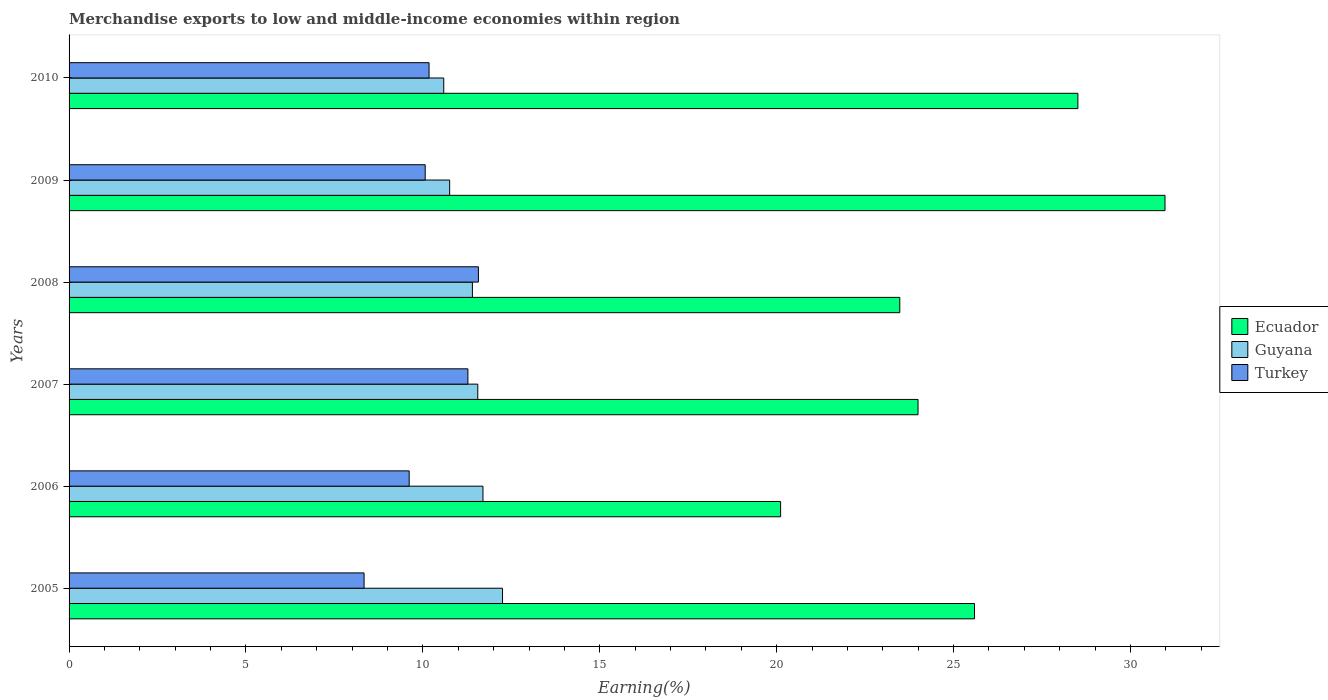Are the number of bars per tick equal to the number of legend labels?
Make the answer very short. Yes. How many bars are there on the 1st tick from the top?
Your answer should be very brief. 3. What is the percentage of amount earned from merchandise exports in Ecuador in 2005?
Provide a succinct answer. 25.59. Across all years, what is the maximum percentage of amount earned from merchandise exports in Ecuador?
Provide a short and direct response. 30.98. Across all years, what is the minimum percentage of amount earned from merchandise exports in Turkey?
Your response must be concise. 8.34. In which year was the percentage of amount earned from merchandise exports in Guyana maximum?
Provide a short and direct response. 2005. In which year was the percentage of amount earned from merchandise exports in Turkey minimum?
Ensure brevity in your answer.  2005. What is the total percentage of amount earned from merchandise exports in Turkey in the graph?
Offer a very short reply. 61.03. What is the difference between the percentage of amount earned from merchandise exports in Ecuador in 2005 and that in 2009?
Keep it short and to the point. -5.38. What is the difference between the percentage of amount earned from merchandise exports in Turkey in 2009 and the percentage of amount earned from merchandise exports in Guyana in 2007?
Keep it short and to the point. -1.49. What is the average percentage of amount earned from merchandise exports in Ecuador per year?
Provide a succinct answer. 25.44. In the year 2010, what is the difference between the percentage of amount earned from merchandise exports in Guyana and percentage of amount earned from merchandise exports in Ecuador?
Your answer should be very brief. -17.92. What is the ratio of the percentage of amount earned from merchandise exports in Ecuador in 2009 to that in 2010?
Make the answer very short. 1.09. Is the percentage of amount earned from merchandise exports in Turkey in 2009 less than that in 2010?
Give a very brief answer. Yes. Is the difference between the percentage of amount earned from merchandise exports in Guyana in 2005 and 2007 greater than the difference between the percentage of amount earned from merchandise exports in Ecuador in 2005 and 2007?
Ensure brevity in your answer.  No. What is the difference between the highest and the second highest percentage of amount earned from merchandise exports in Turkey?
Offer a terse response. 0.3. What is the difference between the highest and the lowest percentage of amount earned from merchandise exports in Ecuador?
Offer a very short reply. 10.86. Is the sum of the percentage of amount earned from merchandise exports in Ecuador in 2008 and 2010 greater than the maximum percentage of amount earned from merchandise exports in Guyana across all years?
Your answer should be compact. Yes. What does the 1st bar from the top in 2006 represents?
Provide a short and direct response. Turkey. What does the 3rd bar from the bottom in 2005 represents?
Provide a short and direct response. Turkey. How many years are there in the graph?
Keep it short and to the point. 6. Are the values on the major ticks of X-axis written in scientific E-notation?
Your answer should be compact. No. Does the graph contain any zero values?
Give a very brief answer. No. Does the graph contain grids?
Ensure brevity in your answer.  No. How many legend labels are there?
Ensure brevity in your answer.  3. How are the legend labels stacked?
Ensure brevity in your answer.  Vertical. What is the title of the graph?
Give a very brief answer. Merchandise exports to low and middle-income economies within region. What is the label or title of the X-axis?
Provide a short and direct response. Earning(%). What is the Earning(%) of Ecuador in 2005?
Your answer should be compact. 25.59. What is the Earning(%) of Guyana in 2005?
Ensure brevity in your answer.  12.25. What is the Earning(%) in Turkey in 2005?
Your response must be concise. 8.34. What is the Earning(%) of Ecuador in 2006?
Keep it short and to the point. 20.11. What is the Earning(%) of Guyana in 2006?
Give a very brief answer. 11.7. What is the Earning(%) of Turkey in 2006?
Offer a terse response. 9.61. What is the Earning(%) of Ecuador in 2007?
Give a very brief answer. 24. What is the Earning(%) in Guyana in 2007?
Your answer should be very brief. 11.55. What is the Earning(%) in Turkey in 2007?
Your response must be concise. 11.27. What is the Earning(%) of Ecuador in 2008?
Offer a terse response. 23.48. What is the Earning(%) in Guyana in 2008?
Offer a terse response. 11.4. What is the Earning(%) of Turkey in 2008?
Make the answer very short. 11.57. What is the Earning(%) in Ecuador in 2009?
Keep it short and to the point. 30.98. What is the Earning(%) in Guyana in 2009?
Offer a terse response. 10.76. What is the Earning(%) in Turkey in 2009?
Keep it short and to the point. 10.07. What is the Earning(%) in Ecuador in 2010?
Your response must be concise. 28.51. What is the Earning(%) in Guyana in 2010?
Make the answer very short. 10.59. What is the Earning(%) of Turkey in 2010?
Offer a terse response. 10.17. Across all years, what is the maximum Earning(%) of Ecuador?
Offer a very short reply. 30.98. Across all years, what is the maximum Earning(%) of Guyana?
Your response must be concise. 12.25. Across all years, what is the maximum Earning(%) of Turkey?
Keep it short and to the point. 11.57. Across all years, what is the minimum Earning(%) in Ecuador?
Your answer should be very brief. 20.11. Across all years, what is the minimum Earning(%) in Guyana?
Make the answer very short. 10.59. Across all years, what is the minimum Earning(%) of Turkey?
Ensure brevity in your answer.  8.34. What is the total Earning(%) in Ecuador in the graph?
Provide a short and direct response. 152.67. What is the total Earning(%) in Guyana in the graph?
Your answer should be very brief. 68.25. What is the total Earning(%) of Turkey in the graph?
Your answer should be compact. 61.03. What is the difference between the Earning(%) of Ecuador in 2005 and that in 2006?
Make the answer very short. 5.48. What is the difference between the Earning(%) of Guyana in 2005 and that in 2006?
Your answer should be compact. 0.55. What is the difference between the Earning(%) of Turkey in 2005 and that in 2006?
Your answer should be compact. -1.28. What is the difference between the Earning(%) of Ecuador in 2005 and that in 2007?
Make the answer very short. 1.6. What is the difference between the Earning(%) in Guyana in 2005 and that in 2007?
Provide a short and direct response. 0.7. What is the difference between the Earning(%) of Turkey in 2005 and that in 2007?
Your response must be concise. -2.93. What is the difference between the Earning(%) in Ecuador in 2005 and that in 2008?
Your answer should be very brief. 2.11. What is the difference between the Earning(%) of Guyana in 2005 and that in 2008?
Your response must be concise. 0.85. What is the difference between the Earning(%) of Turkey in 2005 and that in 2008?
Offer a very short reply. -3.23. What is the difference between the Earning(%) in Ecuador in 2005 and that in 2009?
Your response must be concise. -5.38. What is the difference between the Earning(%) of Guyana in 2005 and that in 2009?
Your answer should be compact. 1.49. What is the difference between the Earning(%) in Turkey in 2005 and that in 2009?
Keep it short and to the point. -1.73. What is the difference between the Earning(%) in Ecuador in 2005 and that in 2010?
Your response must be concise. -2.92. What is the difference between the Earning(%) in Guyana in 2005 and that in 2010?
Make the answer very short. 1.66. What is the difference between the Earning(%) in Turkey in 2005 and that in 2010?
Your answer should be compact. -1.84. What is the difference between the Earning(%) of Ecuador in 2006 and that in 2007?
Your answer should be very brief. -3.88. What is the difference between the Earning(%) of Guyana in 2006 and that in 2007?
Keep it short and to the point. 0.15. What is the difference between the Earning(%) of Turkey in 2006 and that in 2007?
Keep it short and to the point. -1.66. What is the difference between the Earning(%) in Ecuador in 2006 and that in 2008?
Offer a terse response. -3.37. What is the difference between the Earning(%) of Guyana in 2006 and that in 2008?
Keep it short and to the point. 0.3. What is the difference between the Earning(%) of Turkey in 2006 and that in 2008?
Offer a very short reply. -1.96. What is the difference between the Earning(%) in Ecuador in 2006 and that in 2009?
Give a very brief answer. -10.86. What is the difference between the Earning(%) of Guyana in 2006 and that in 2009?
Keep it short and to the point. 0.94. What is the difference between the Earning(%) of Turkey in 2006 and that in 2009?
Offer a terse response. -0.45. What is the difference between the Earning(%) of Ecuador in 2006 and that in 2010?
Offer a very short reply. -8.4. What is the difference between the Earning(%) in Guyana in 2006 and that in 2010?
Your response must be concise. 1.11. What is the difference between the Earning(%) of Turkey in 2006 and that in 2010?
Your answer should be compact. -0.56. What is the difference between the Earning(%) in Ecuador in 2007 and that in 2008?
Offer a very short reply. 0.52. What is the difference between the Earning(%) in Guyana in 2007 and that in 2008?
Offer a very short reply. 0.15. What is the difference between the Earning(%) in Turkey in 2007 and that in 2008?
Ensure brevity in your answer.  -0.3. What is the difference between the Earning(%) in Ecuador in 2007 and that in 2009?
Give a very brief answer. -6.98. What is the difference between the Earning(%) of Guyana in 2007 and that in 2009?
Your answer should be very brief. 0.8. What is the difference between the Earning(%) of Turkey in 2007 and that in 2009?
Your response must be concise. 1.21. What is the difference between the Earning(%) of Ecuador in 2007 and that in 2010?
Keep it short and to the point. -4.52. What is the difference between the Earning(%) of Guyana in 2007 and that in 2010?
Provide a short and direct response. 0.96. What is the difference between the Earning(%) in Turkey in 2007 and that in 2010?
Ensure brevity in your answer.  1.1. What is the difference between the Earning(%) of Ecuador in 2008 and that in 2009?
Your response must be concise. -7.5. What is the difference between the Earning(%) of Guyana in 2008 and that in 2009?
Keep it short and to the point. 0.64. What is the difference between the Earning(%) of Turkey in 2008 and that in 2009?
Provide a succinct answer. 1.5. What is the difference between the Earning(%) of Ecuador in 2008 and that in 2010?
Give a very brief answer. -5.03. What is the difference between the Earning(%) of Guyana in 2008 and that in 2010?
Give a very brief answer. 0.81. What is the difference between the Earning(%) of Turkey in 2008 and that in 2010?
Ensure brevity in your answer.  1.39. What is the difference between the Earning(%) in Ecuador in 2009 and that in 2010?
Your response must be concise. 2.46. What is the difference between the Earning(%) of Turkey in 2009 and that in 2010?
Provide a short and direct response. -0.11. What is the difference between the Earning(%) of Ecuador in 2005 and the Earning(%) of Guyana in 2006?
Provide a succinct answer. 13.89. What is the difference between the Earning(%) of Ecuador in 2005 and the Earning(%) of Turkey in 2006?
Your answer should be very brief. 15.98. What is the difference between the Earning(%) in Guyana in 2005 and the Earning(%) in Turkey in 2006?
Provide a short and direct response. 2.64. What is the difference between the Earning(%) of Ecuador in 2005 and the Earning(%) of Guyana in 2007?
Ensure brevity in your answer.  14.04. What is the difference between the Earning(%) in Ecuador in 2005 and the Earning(%) in Turkey in 2007?
Provide a succinct answer. 14.32. What is the difference between the Earning(%) in Guyana in 2005 and the Earning(%) in Turkey in 2007?
Make the answer very short. 0.98. What is the difference between the Earning(%) of Ecuador in 2005 and the Earning(%) of Guyana in 2008?
Keep it short and to the point. 14.19. What is the difference between the Earning(%) in Ecuador in 2005 and the Earning(%) in Turkey in 2008?
Offer a terse response. 14.02. What is the difference between the Earning(%) in Guyana in 2005 and the Earning(%) in Turkey in 2008?
Your response must be concise. 0.68. What is the difference between the Earning(%) in Ecuador in 2005 and the Earning(%) in Guyana in 2009?
Make the answer very short. 14.83. What is the difference between the Earning(%) in Ecuador in 2005 and the Earning(%) in Turkey in 2009?
Make the answer very short. 15.53. What is the difference between the Earning(%) in Guyana in 2005 and the Earning(%) in Turkey in 2009?
Your response must be concise. 2.19. What is the difference between the Earning(%) in Ecuador in 2005 and the Earning(%) in Guyana in 2010?
Ensure brevity in your answer.  15. What is the difference between the Earning(%) of Ecuador in 2005 and the Earning(%) of Turkey in 2010?
Offer a terse response. 15.42. What is the difference between the Earning(%) of Guyana in 2005 and the Earning(%) of Turkey in 2010?
Your answer should be very brief. 2.08. What is the difference between the Earning(%) in Ecuador in 2006 and the Earning(%) in Guyana in 2007?
Your answer should be compact. 8.56. What is the difference between the Earning(%) in Ecuador in 2006 and the Earning(%) in Turkey in 2007?
Give a very brief answer. 8.84. What is the difference between the Earning(%) of Guyana in 2006 and the Earning(%) of Turkey in 2007?
Give a very brief answer. 0.43. What is the difference between the Earning(%) of Ecuador in 2006 and the Earning(%) of Guyana in 2008?
Ensure brevity in your answer.  8.71. What is the difference between the Earning(%) in Ecuador in 2006 and the Earning(%) in Turkey in 2008?
Make the answer very short. 8.54. What is the difference between the Earning(%) in Guyana in 2006 and the Earning(%) in Turkey in 2008?
Your answer should be very brief. 0.13. What is the difference between the Earning(%) in Ecuador in 2006 and the Earning(%) in Guyana in 2009?
Provide a short and direct response. 9.35. What is the difference between the Earning(%) of Ecuador in 2006 and the Earning(%) of Turkey in 2009?
Provide a short and direct response. 10.05. What is the difference between the Earning(%) in Guyana in 2006 and the Earning(%) in Turkey in 2009?
Your response must be concise. 1.63. What is the difference between the Earning(%) in Ecuador in 2006 and the Earning(%) in Guyana in 2010?
Your response must be concise. 9.52. What is the difference between the Earning(%) of Ecuador in 2006 and the Earning(%) of Turkey in 2010?
Your response must be concise. 9.94. What is the difference between the Earning(%) of Guyana in 2006 and the Earning(%) of Turkey in 2010?
Give a very brief answer. 1.52. What is the difference between the Earning(%) of Ecuador in 2007 and the Earning(%) of Guyana in 2008?
Keep it short and to the point. 12.6. What is the difference between the Earning(%) in Ecuador in 2007 and the Earning(%) in Turkey in 2008?
Make the answer very short. 12.43. What is the difference between the Earning(%) in Guyana in 2007 and the Earning(%) in Turkey in 2008?
Your answer should be compact. -0.02. What is the difference between the Earning(%) in Ecuador in 2007 and the Earning(%) in Guyana in 2009?
Your answer should be very brief. 13.24. What is the difference between the Earning(%) of Ecuador in 2007 and the Earning(%) of Turkey in 2009?
Provide a succinct answer. 13.93. What is the difference between the Earning(%) of Guyana in 2007 and the Earning(%) of Turkey in 2009?
Ensure brevity in your answer.  1.49. What is the difference between the Earning(%) in Ecuador in 2007 and the Earning(%) in Guyana in 2010?
Your answer should be very brief. 13.41. What is the difference between the Earning(%) of Ecuador in 2007 and the Earning(%) of Turkey in 2010?
Your answer should be compact. 13.82. What is the difference between the Earning(%) in Guyana in 2007 and the Earning(%) in Turkey in 2010?
Your response must be concise. 1.38. What is the difference between the Earning(%) of Ecuador in 2008 and the Earning(%) of Guyana in 2009?
Offer a very short reply. 12.72. What is the difference between the Earning(%) of Ecuador in 2008 and the Earning(%) of Turkey in 2009?
Your answer should be very brief. 13.41. What is the difference between the Earning(%) of Guyana in 2008 and the Earning(%) of Turkey in 2009?
Offer a terse response. 1.33. What is the difference between the Earning(%) of Ecuador in 2008 and the Earning(%) of Guyana in 2010?
Your answer should be very brief. 12.89. What is the difference between the Earning(%) in Ecuador in 2008 and the Earning(%) in Turkey in 2010?
Provide a succinct answer. 13.3. What is the difference between the Earning(%) in Guyana in 2008 and the Earning(%) in Turkey in 2010?
Keep it short and to the point. 1.23. What is the difference between the Earning(%) of Ecuador in 2009 and the Earning(%) of Guyana in 2010?
Offer a very short reply. 20.39. What is the difference between the Earning(%) of Ecuador in 2009 and the Earning(%) of Turkey in 2010?
Keep it short and to the point. 20.8. What is the difference between the Earning(%) of Guyana in 2009 and the Earning(%) of Turkey in 2010?
Provide a short and direct response. 0.58. What is the average Earning(%) of Ecuador per year?
Provide a succinct answer. 25.44. What is the average Earning(%) in Guyana per year?
Your answer should be very brief. 11.37. What is the average Earning(%) of Turkey per year?
Offer a terse response. 10.17. In the year 2005, what is the difference between the Earning(%) of Ecuador and Earning(%) of Guyana?
Keep it short and to the point. 13.34. In the year 2005, what is the difference between the Earning(%) of Ecuador and Earning(%) of Turkey?
Provide a succinct answer. 17.25. In the year 2005, what is the difference between the Earning(%) in Guyana and Earning(%) in Turkey?
Provide a succinct answer. 3.91. In the year 2006, what is the difference between the Earning(%) of Ecuador and Earning(%) of Guyana?
Offer a terse response. 8.41. In the year 2006, what is the difference between the Earning(%) of Ecuador and Earning(%) of Turkey?
Make the answer very short. 10.5. In the year 2006, what is the difference between the Earning(%) of Guyana and Earning(%) of Turkey?
Your answer should be compact. 2.09. In the year 2007, what is the difference between the Earning(%) of Ecuador and Earning(%) of Guyana?
Keep it short and to the point. 12.44. In the year 2007, what is the difference between the Earning(%) in Ecuador and Earning(%) in Turkey?
Your response must be concise. 12.72. In the year 2007, what is the difference between the Earning(%) of Guyana and Earning(%) of Turkey?
Offer a terse response. 0.28. In the year 2008, what is the difference between the Earning(%) in Ecuador and Earning(%) in Guyana?
Keep it short and to the point. 12.08. In the year 2008, what is the difference between the Earning(%) of Ecuador and Earning(%) of Turkey?
Offer a terse response. 11.91. In the year 2008, what is the difference between the Earning(%) in Guyana and Earning(%) in Turkey?
Offer a very short reply. -0.17. In the year 2009, what is the difference between the Earning(%) of Ecuador and Earning(%) of Guyana?
Make the answer very short. 20.22. In the year 2009, what is the difference between the Earning(%) in Ecuador and Earning(%) in Turkey?
Offer a very short reply. 20.91. In the year 2009, what is the difference between the Earning(%) of Guyana and Earning(%) of Turkey?
Give a very brief answer. 0.69. In the year 2010, what is the difference between the Earning(%) in Ecuador and Earning(%) in Guyana?
Make the answer very short. 17.92. In the year 2010, what is the difference between the Earning(%) in Ecuador and Earning(%) in Turkey?
Your answer should be compact. 18.34. In the year 2010, what is the difference between the Earning(%) in Guyana and Earning(%) in Turkey?
Provide a short and direct response. 0.42. What is the ratio of the Earning(%) of Ecuador in 2005 to that in 2006?
Make the answer very short. 1.27. What is the ratio of the Earning(%) in Guyana in 2005 to that in 2006?
Your response must be concise. 1.05. What is the ratio of the Earning(%) in Turkey in 2005 to that in 2006?
Provide a short and direct response. 0.87. What is the ratio of the Earning(%) of Ecuador in 2005 to that in 2007?
Offer a very short reply. 1.07. What is the ratio of the Earning(%) of Guyana in 2005 to that in 2007?
Offer a very short reply. 1.06. What is the ratio of the Earning(%) of Turkey in 2005 to that in 2007?
Your answer should be very brief. 0.74. What is the ratio of the Earning(%) of Ecuador in 2005 to that in 2008?
Give a very brief answer. 1.09. What is the ratio of the Earning(%) in Guyana in 2005 to that in 2008?
Offer a terse response. 1.07. What is the ratio of the Earning(%) of Turkey in 2005 to that in 2008?
Your answer should be compact. 0.72. What is the ratio of the Earning(%) of Ecuador in 2005 to that in 2009?
Provide a short and direct response. 0.83. What is the ratio of the Earning(%) of Guyana in 2005 to that in 2009?
Make the answer very short. 1.14. What is the ratio of the Earning(%) of Turkey in 2005 to that in 2009?
Provide a succinct answer. 0.83. What is the ratio of the Earning(%) of Ecuador in 2005 to that in 2010?
Your response must be concise. 0.9. What is the ratio of the Earning(%) of Guyana in 2005 to that in 2010?
Provide a succinct answer. 1.16. What is the ratio of the Earning(%) in Turkey in 2005 to that in 2010?
Your answer should be compact. 0.82. What is the ratio of the Earning(%) of Ecuador in 2006 to that in 2007?
Keep it short and to the point. 0.84. What is the ratio of the Earning(%) of Guyana in 2006 to that in 2007?
Provide a succinct answer. 1.01. What is the ratio of the Earning(%) of Turkey in 2006 to that in 2007?
Offer a very short reply. 0.85. What is the ratio of the Earning(%) in Ecuador in 2006 to that in 2008?
Provide a short and direct response. 0.86. What is the ratio of the Earning(%) of Guyana in 2006 to that in 2008?
Keep it short and to the point. 1.03. What is the ratio of the Earning(%) in Turkey in 2006 to that in 2008?
Keep it short and to the point. 0.83. What is the ratio of the Earning(%) of Ecuador in 2006 to that in 2009?
Offer a very short reply. 0.65. What is the ratio of the Earning(%) in Guyana in 2006 to that in 2009?
Keep it short and to the point. 1.09. What is the ratio of the Earning(%) of Turkey in 2006 to that in 2009?
Offer a terse response. 0.95. What is the ratio of the Earning(%) in Ecuador in 2006 to that in 2010?
Your answer should be compact. 0.71. What is the ratio of the Earning(%) of Guyana in 2006 to that in 2010?
Provide a succinct answer. 1.1. What is the ratio of the Earning(%) in Turkey in 2006 to that in 2010?
Give a very brief answer. 0.94. What is the ratio of the Earning(%) in Guyana in 2007 to that in 2008?
Offer a terse response. 1.01. What is the ratio of the Earning(%) of Turkey in 2007 to that in 2008?
Your answer should be compact. 0.97. What is the ratio of the Earning(%) of Ecuador in 2007 to that in 2009?
Your answer should be very brief. 0.77. What is the ratio of the Earning(%) of Guyana in 2007 to that in 2009?
Offer a terse response. 1.07. What is the ratio of the Earning(%) in Turkey in 2007 to that in 2009?
Provide a short and direct response. 1.12. What is the ratio of the Earning(%) in Ecuador in 2007 to that in 2010?
Keep it short and to the point. 0.84. What is the ratio of the Earning(%) of Guyana in 2007 to that in 2010?
Keep it short and to the point. 1.09. What is the ratio of the Earning(%) in Turkey in 2007 to that in 2010?
Provide a succinct answer. 1.11. What is the ratio of the Earning(%) in Ecuador in 2008 to that in 2009?
Offer a terse response. 0.76. What is the ratio of the Earning(%) in Guyana in 2008 to that in 2009?
Your answer should be very brief. 1.06. What is the ratio of the Earning(%) in Turkey in 2008 to that in 2009?
Offer a terse response. 1.15. What is the ratio of the Earning(%) of Ecuador in 2008 to that in 2010?
Your answer should be very brief. 0.82. What is the ratio of the Earning(%) of Guyana in 2008 to that in 2010?
Provide a short and direct response. 1.08. What is the ratio of the Earning(%) of Turkey in 2008 to that in 2010?
Ensure brevity in your answer.  1.14. What is the ratio of the Earning(%) of Ecuador in 2009 to that in 2010?
Provide a short and direct response. 1.09. What is the ratio of the Earning(%) of Guyana in 2009 to that in 2010?
Keep it short and to the point. 1.02. What is the ratio of the Earning(%) in Turkey in 2009 to that in 2010?
Give a very brief answer. 0.99. What is the difference between the highest and the second highest Earning(%) in Ecuador?
Make the answer very short. 2.46. What is the difference between the highest and the second highest Earning(%) in Guyana?
Give a very brief answer. 0.55. What is the difference between the highest and the second highest Earning(%) in Turkey?
Ensure brevity in your answer.  0.3. What is the difference between the highest and the lowest Earning(%) in Ecuador?
Your answer should be very brief. 10.86. What is the difference between the highest and the lowest Earning(%) of Guyana?
Give a very brief answer. 1.66. What is the difference between the highest and the lowest Earning(%) of Turkey?
Offer a terse response. 3.23. 